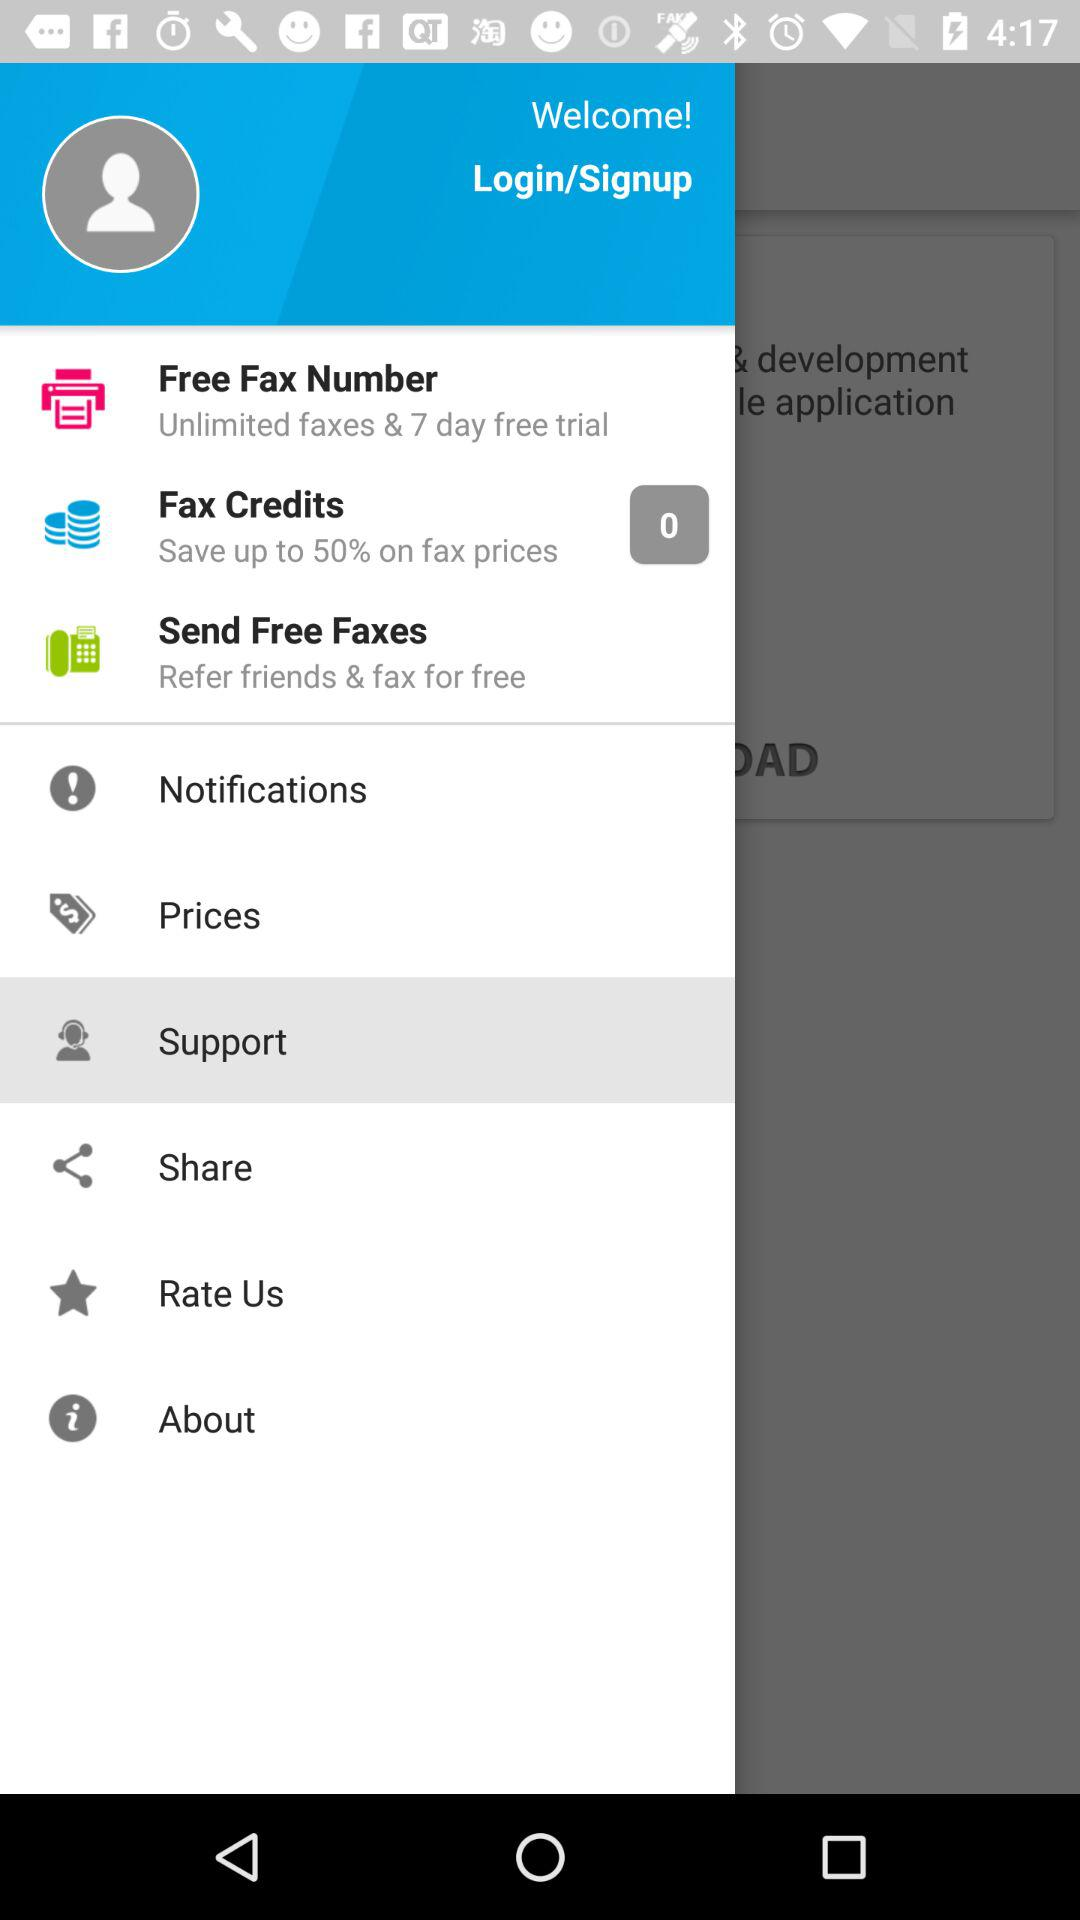What is the given value of fax credits? The given value is 0. 